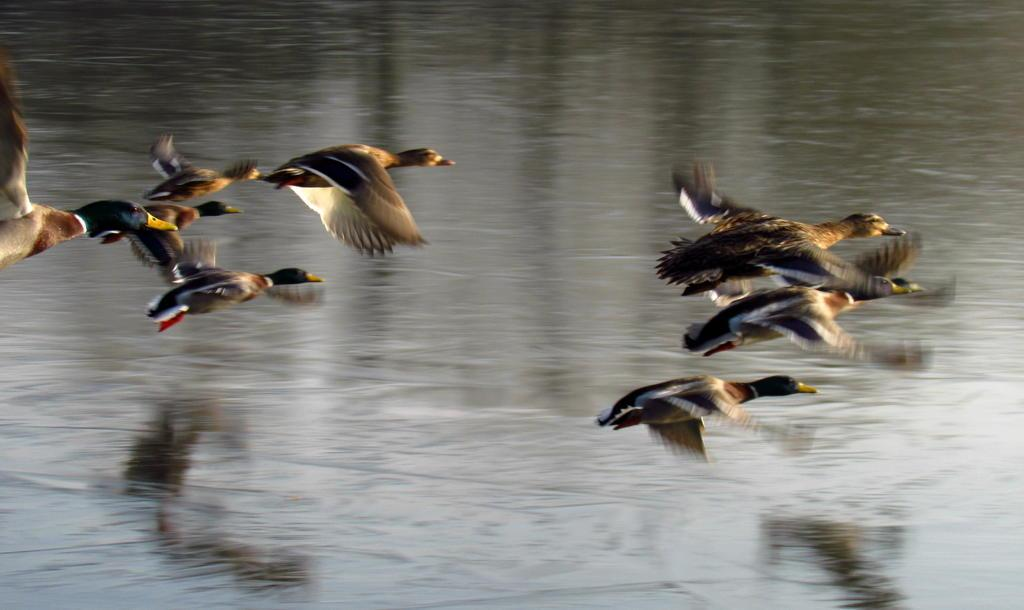What is happening in the image? Birds are flying in the image. What is the primary element in which the birds are situated? There is water visible in the image, and the birds are flying above it. What type of jelly can be seen floating in the water in the image? There is no jelly present in the image; it features birds flying above water. 